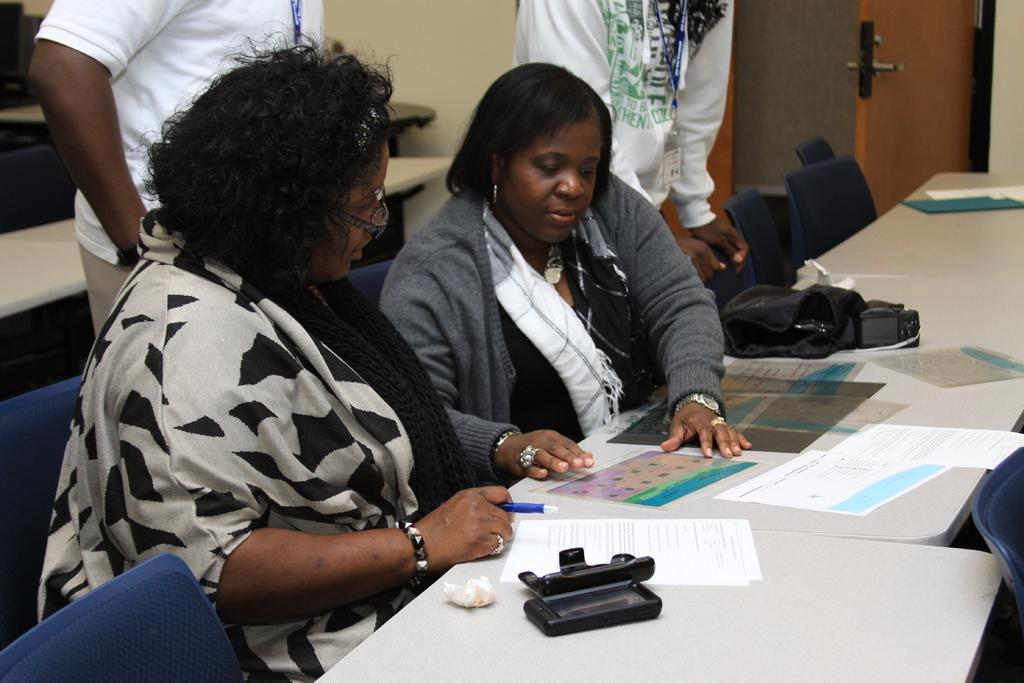In one or two sentences, can you explain what this image depicts? In this image there are two women seated in chairs, in front of the women there is a table, on the table there are papers and a bag, behind the two women there are two men standing and behind them there are tables and chairs, beside the two men there is a door. 